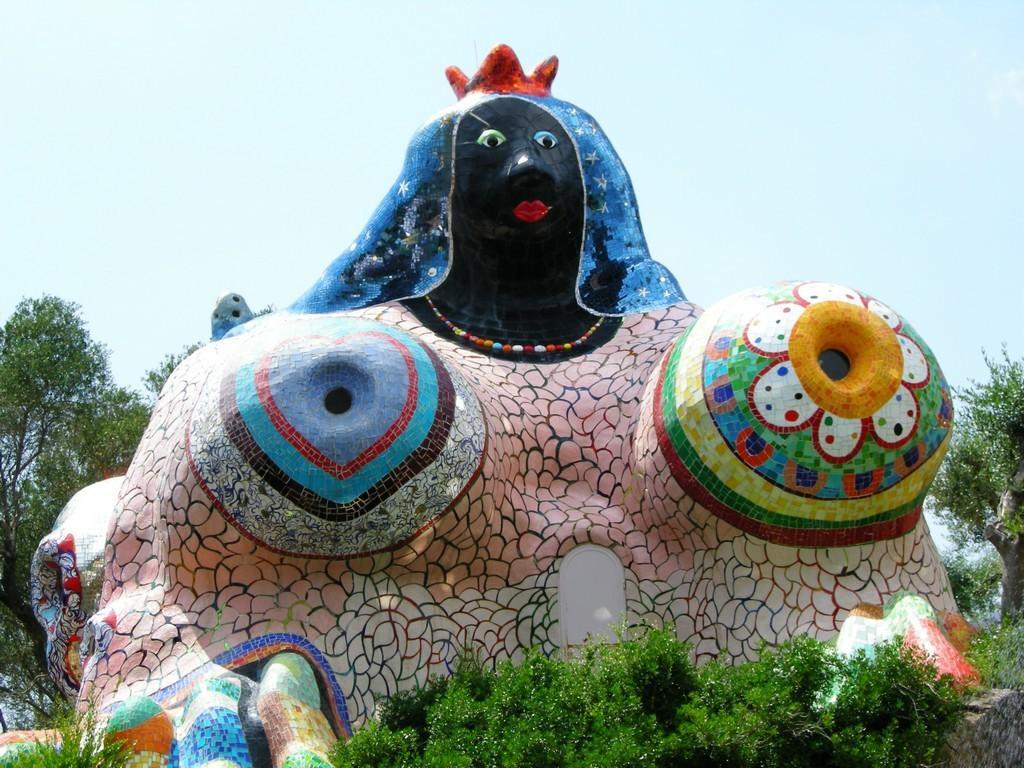Can you describe this image briefly? At the center of the image there is a sculpture, around that there are trees. In the background there is the sky. 